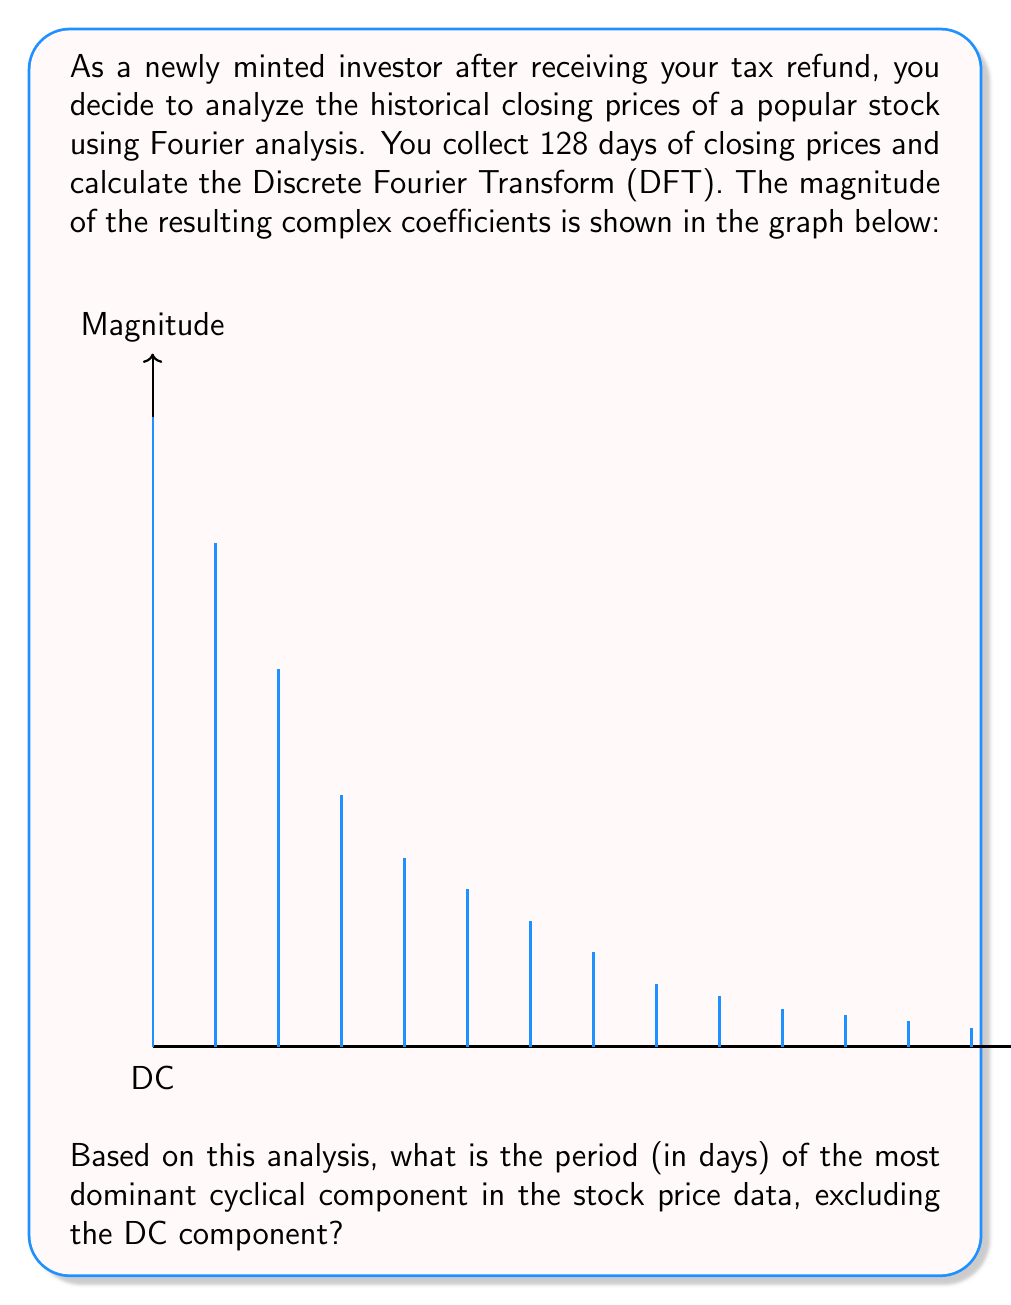Teach me how to tackle this problem. To solve this problem, we need to follow these steps:

1) First, recall that for a DFT of N points, the k-th frequency component represents a cycle that completes k times over the entire N-point sequence.

2) In this case, we have 128 days of data, so N = 128.

3) Looking at the graph, we see that the largest magnitude (excluding the DC component at frequency 0) is at the 2nd frequency component (index 1 if we start counting at 0).

4) This means the dominant cycle completes 1 full cycle over the 128-day period.

5) To calculate the period, we use the formula:

   $$ \text{Period} = \frac{N}{\text{Frequency Index}} $$

6) Plugging in our values:

   $$ \text{Period} = \frac{128}{1} = 128 \text{ days} $$

Therefore, the most dominant cyclical component has a period of 128 days.
Answer: 128 days 